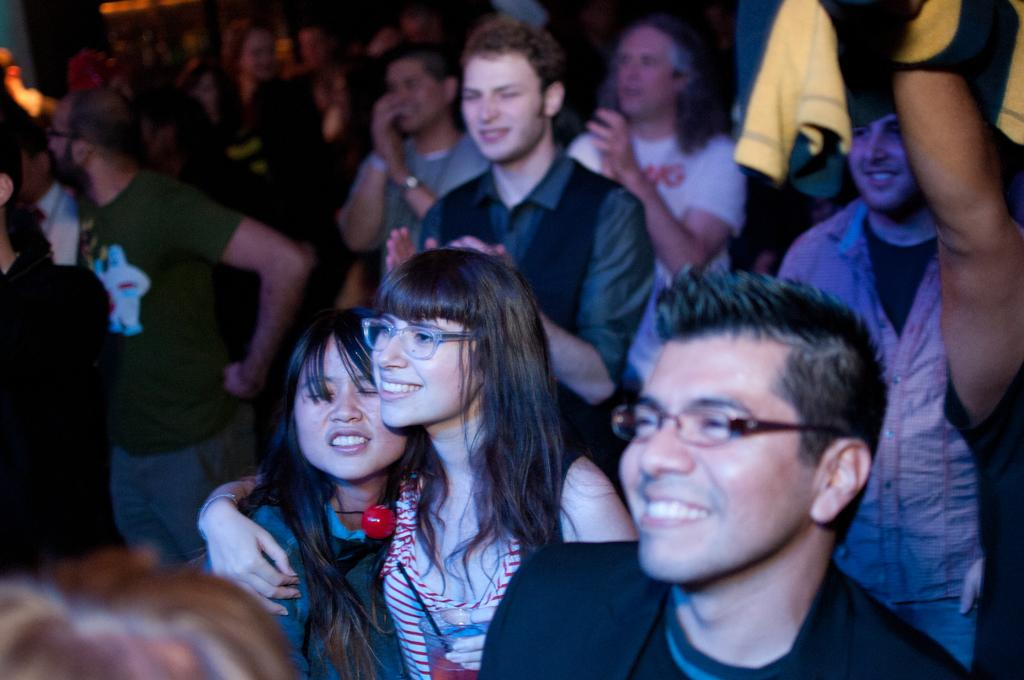What is happening in the image? There are people standing in the image. Can you describe the expressions of the people? Some of the people are smiling. What is a person on the right side holding? A person on the right side is holding a cloth. Are there any specific accessories worn by the people in the image? Two persons in the front are wearing spectacles. What type of corn is being harvested by the parent in the image? There is no corn or parent present in the image. Is there any blood visible on the people in the image? There is no blood visible on the people in the image. 